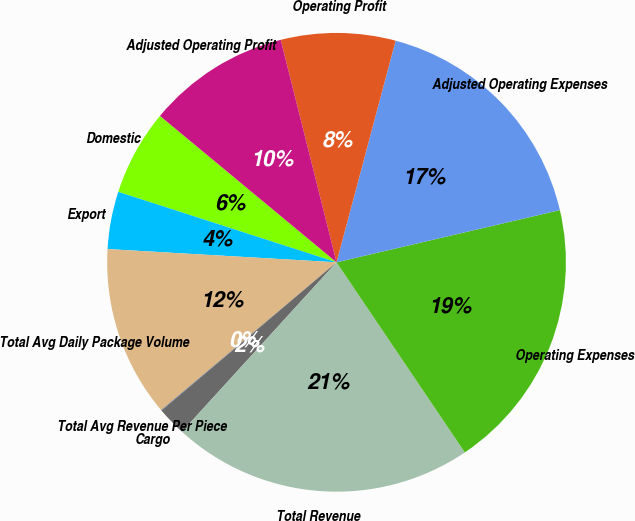<chart> <loc_0><loc_0><loc_500><loc_500><pie_chart><fcel>Domestic<fcel>Export<fcel>Total Avg Daily Package Volume<fcel>Total Avg Revenue Per Piece<fcel>Cargo<fcel>Total Revenue<fcel>Operating Expenses<fcel>Adjusted Operating Expenses<fcel>Operating Profit<fcel>Adjusted Operating Profit<nl><fcel>6.05%<fcel>4.05%<fcel>12.08%<fcel>0.03%<fcel>2.04%<fcel>21.22%<fcel>19.21%<fcel>17.2%<fcel>8.06%<fcel>10.07%<nl></chart> 